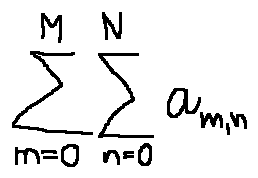Convert formula to latex. <formula><loc_0><loc_0><loc_500><loc_500>\sum \lim i t s _ { m = 0 } ^ { M } \sum \lim i t s _ { n = 0 } ^ { N } a _ { m , n }</formula> 